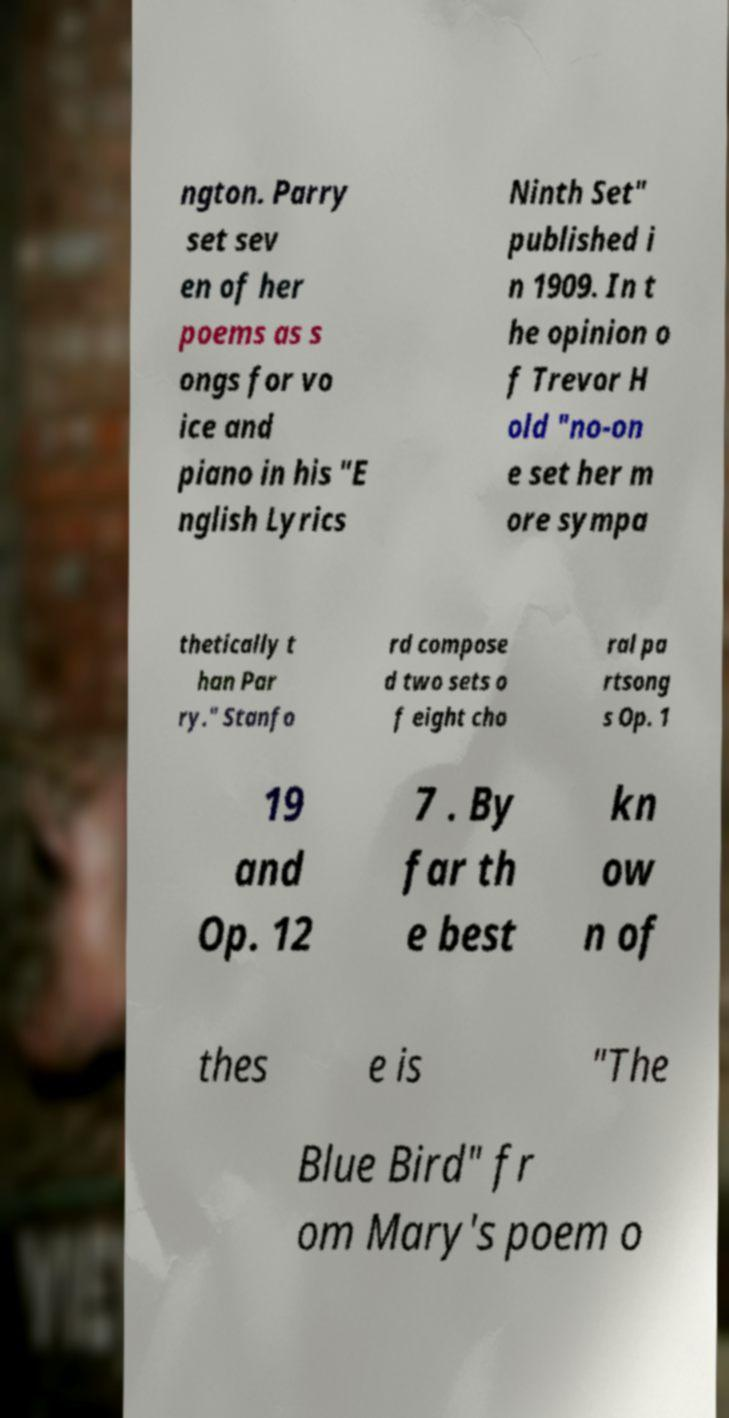Can you accurately transcribe the text from the provided image for me? ngton. Parry set sev en of her poems as s ongs for vo ice and piano in his "E nglish Lyrics Ninth Set" published i n 1909. In t he opinion o f Trevor H old "no-on e set her m ore sympa thetically t han Par ry." Stanfo rd compose d two sets o f eight cho ral pa rtsong s Op. 1 19 and Op. 12 7 . By far th e best kn ow n of thes e is "The Blue Bird" fr om Mary's poem o 